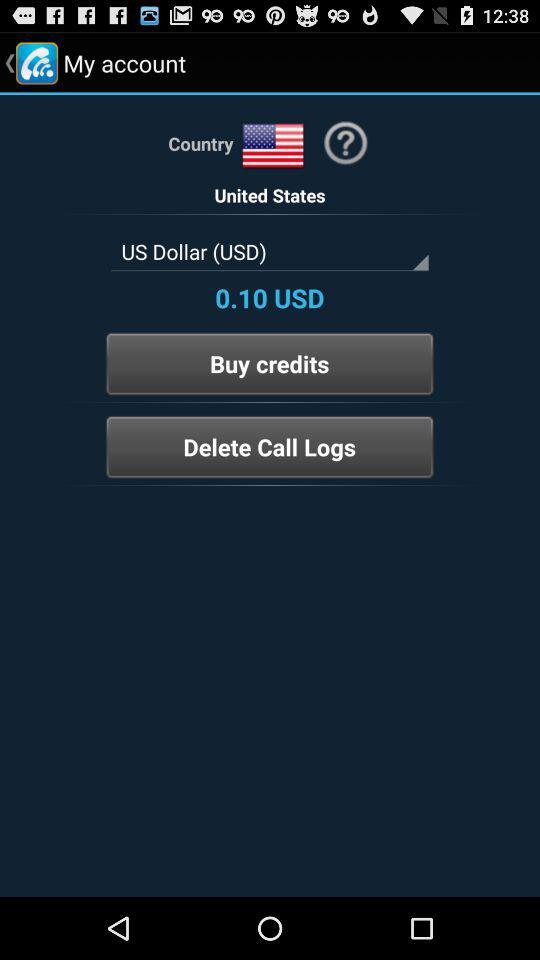What is the currency name? The currency name is the US Dollar (USD). 